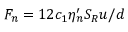<formula> <loc_0><loc_0><loc_500><loc_500>F _ { n } = 1 2 c _ { 1 } \eta _ { n } ^ { \prime } S _ { R } u / d</formula> 